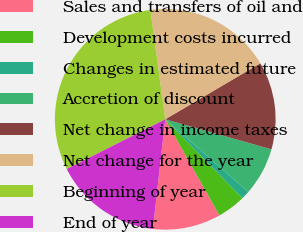Convert chart to OTSL. <chart><loc_0><loc_0><loc_500><loc_500><pie_chart><fcel>Sales and transfers of oil and<fcel>Development costs incurred<fcel>Changes in estimated future<fcel>Accretion of discount<fcel>Net change in income taxes<fcel>Net change for the year<fcel>Beginning of year<fcel>End of year<nl><fcel>9.96%<fcel>4.15%<fcel>1.24%<fcel>7.05%<fcel>12.86%<fcel>18.67%<fcel>30.3%<fcel>15.77%<nl></chart> 